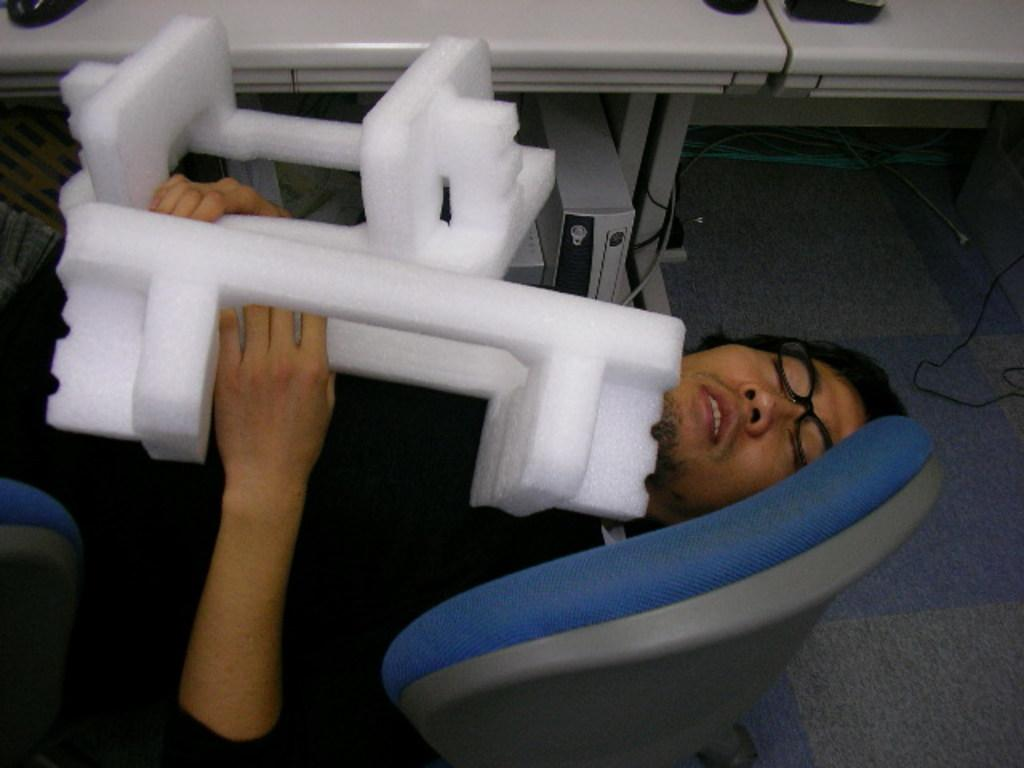Who is present in the image? There is a person in the image. What is the person doing in the image? The person is lying on chairs. What is the person holding in the image? The person is holding thermocol sheets. What other furniture can be seen in the image? There are tables visible in the image. What is the price of the grass in the image? There is no grass present in the image, so it is not possible to determine the price of any grass. 